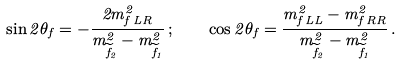Convert formula to latex. <formula><loc_0><loc_0><loc_500><loc_500>\sin 2 \theta _ { f } = - \frac { 2 m ^ { 2 } _ { f \, L R } } { m ^ { 2 } _ { \widetilde { f } _ { 2 } } - m ^ { 2 } _ { \widetilde { f } _ { 1 } } } \, ; \quad \cos 2 \theta _ { f } = \frac { m ^ { 2 } _ { f \, L L } - m ^ { 2 } _ { f \, R R } } { m ^ { 2 } _ { \widetilde { f } _ { 2 } } - m ^ { 2 } _ { \widetilde { f } _ { 1 } } } \, .</formula> 